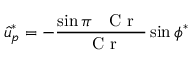Convert formula to latex. <formula><loc_0><loc_0><loc_500><loc_500>\hat { u } _ { p } ^ { * } = - \frac { \sin \pi { C r } } { { C r } } \sin \phi ^ { * }</formula> 